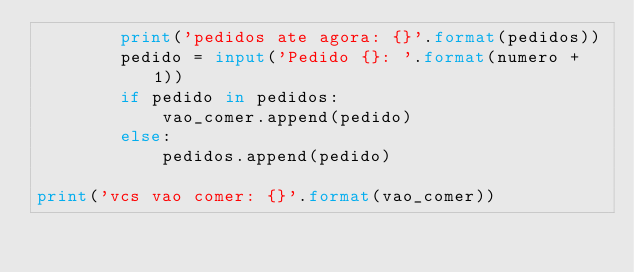<code> <loc_0><loc_0><loc_500><loc_500><_Python_>        print('pedidos ate agora: {}'.format(pedidos))
        pedido = input('Pedido {}: '.format(numero + 1))
        if pedido in pedidos:
            vao_comer.append(pedido)
        else:
            pedidos.append(pedido)

print('vcs vao comer: {}'.format(vao_comer))

</code> 